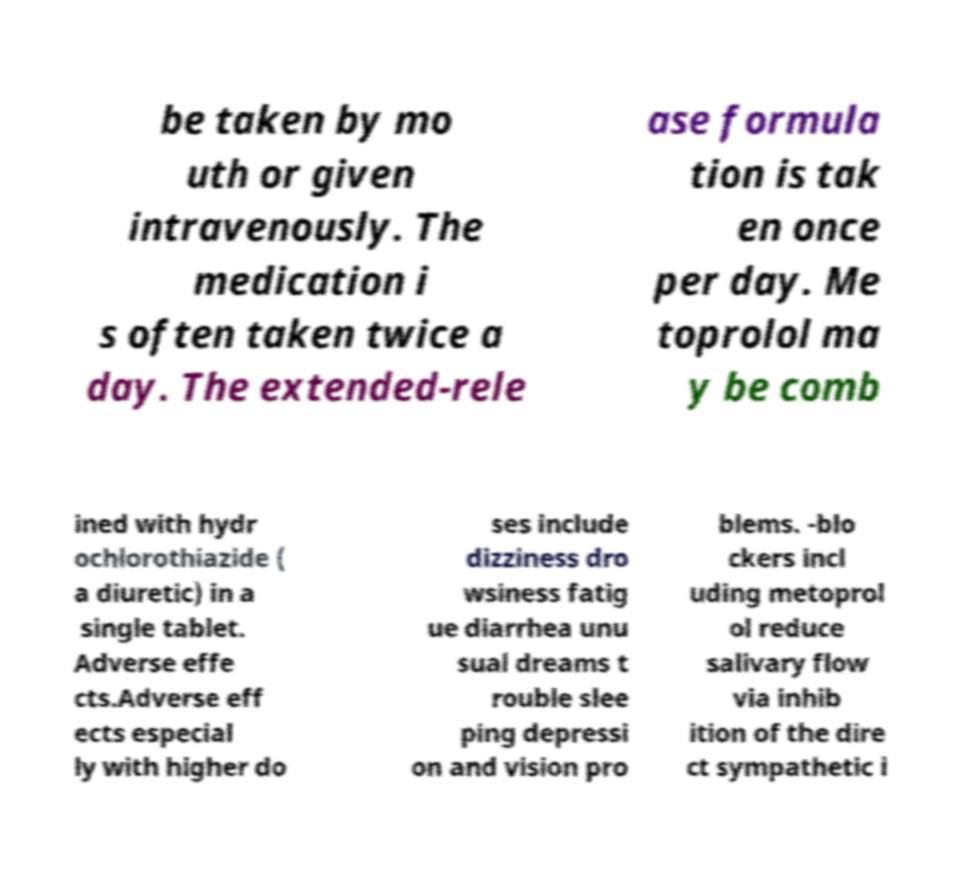Can you accurately transcribe the text from the provided image for me? be taken by mo uth or given intravenously. The medication i s often taken twice a day. The extended-rele ase formula tion is tak en once per day. Me toprolol ma y be comb ined with hydr ochlorothiazide ( a diuretic) in a single tablet. Adverse effe cts.Adverse eff ects especial ly with higher do ses include dizziness dro wsiness fatig ue diarrhea unu sual dreams t rouble slee ping depressi on and vision pro blems. -blo ckers incl uding metoprol ol reduce salivary flow via inhib ition of the dire ct sympathetic i 